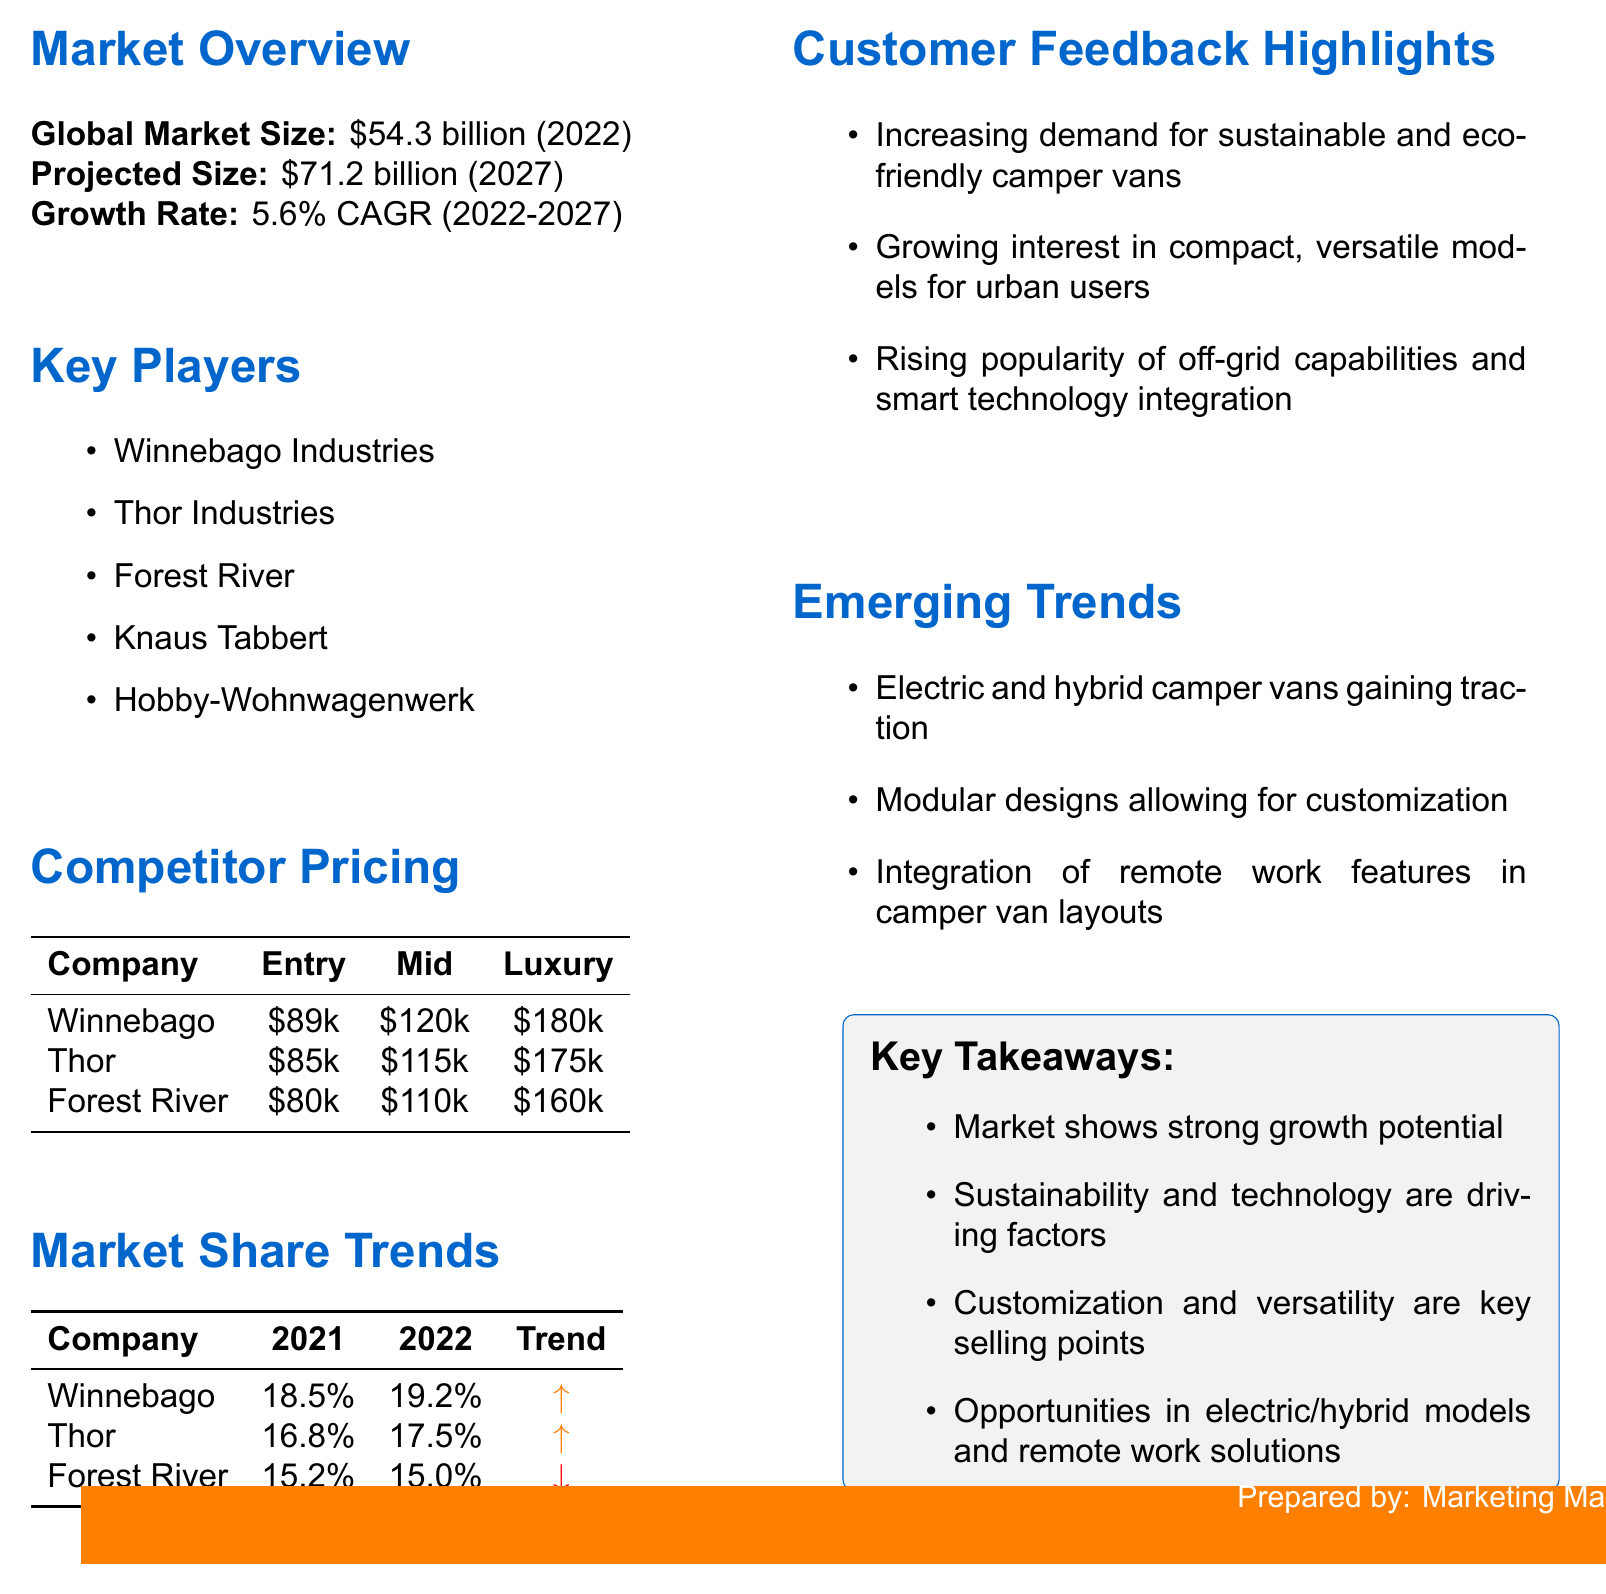What is the global market size in 2022? The document states that the global market size is \$54.3 billion in 2022.
Answer: \$54.3 billion What is the projected market size by 2027? The document mentions the projected market size at \$71.2 billion by 2027.
Answer: \$71.2 billion What is the growth rate from 2022 to 2027? The growth rate indicated in the document is 5.6% CAGR from 2022 to 2027.
Answer: 5.6% CAGR Which company has the highest entry-level price? By examining the competitor pricing section, Winnebago Industries has the highest entry-level price at \$89,000.
Answer: Winnebago Industries What was the market share of Thor Industries in 2022? The document reports that Thor Industries had a market share of 17.5% in 2022.
Answer: 17.5% Which company experienced a slight decrease in market share from 2021 to 2022? According to the market share trends, Forest River experienced a slight decrease in market share.
Answer: Forest River What emerging trend is related to camper vans? The document highlights several emerging trends, including electric and hybrid camper vans gaining traction.
Answer: Electric and hybrid camper vans What customer feedback trend is noted in the report? One of the customer feedback highlights is the increasing demand for sustainable and eco-friendly camper vans.
Answer: Sustainable and eco-friendly camper vans What key takeaway emphasizes customization? The key takeaway points out that customization and versatility are key selling points.
Answer: Customization and versatility Which company had a market share trend that was increasing? The market share trends indicate that both Winnebago Industries and Thor Industries had increasing market share trends.
Answer: Winnebago Industries and Thor Industries 